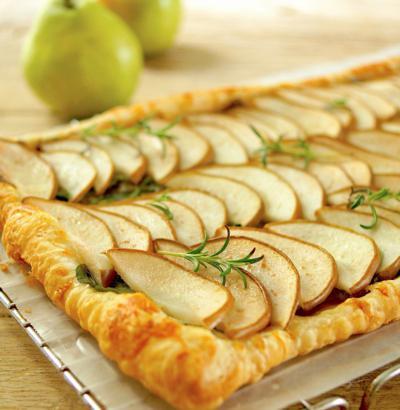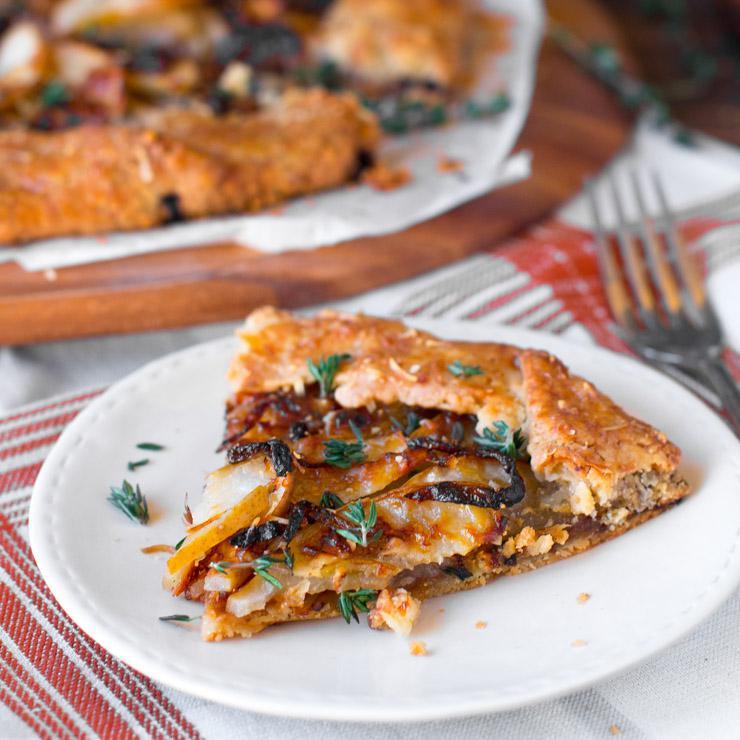The first image is the image on the left, the second image is the image on the right. Given the left and right images, does the statement "In the image on the left, the dough products are arranged neatly on a baking sheet." hold true? Answer yes or no. Yes. The first image is the image on the left, the second image is the image on the right. For the images displayed, is the sentence "The left image features half-circle shapes on a rectangle with edges, and the right image features something shaped like a slice of pie." factually correct? Answer yes or no. Yes. 